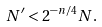<formula> <loc_0><loc_0><loc_500><loc_500>N ^ { \prime } < 2 ^ { - n / 4 } N .</formula> 